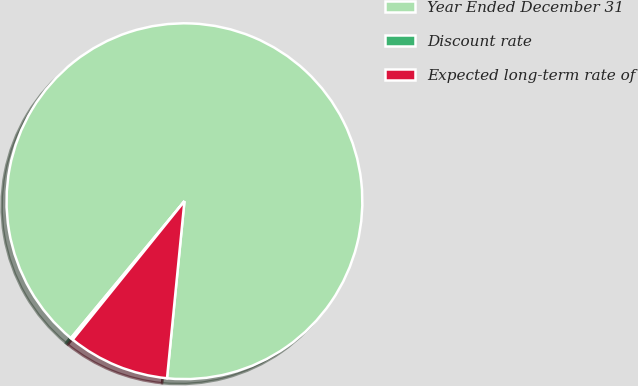Convert chart to OTSL. <chart><loc_0><loc_0><loc_500><loc_500><pie_chart><fcel>Year Ended December 31<fcel>Discount rate<fcel>Expected long-term rate of<nl><fcel>90.54%<fcel>0.21%<fcel>9.25%<nl></chart> 